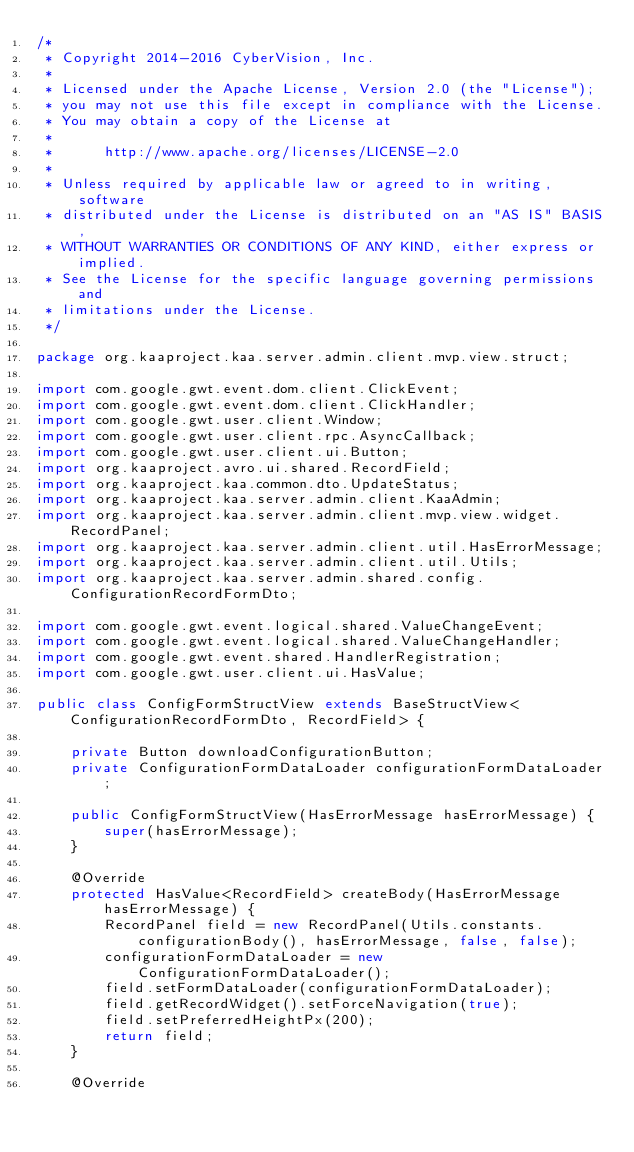Convert code to text. <code><loc_0><loc_0><loc_500><loc_500><_Java_>/*
 * Copyright 2014-2016 CyberVision, Inc.
 *
 * Licensed under the Apache License, Version 2.0 (the "License");
 * you may not use this file except in compliance with the License.
 * You may obtain a copy of the License at
 *
 *      http://www.apache.org/licenses/LICENSE-2.0
 *
 * Unless required by applicable law or agreed to in writing, software
 * distributed under the License is distributed on an "AS IS" BASIS,
 * WITHOUT WARRANTIES OR CONDITIONS OF ANY KIND, either express or implied.
 * See the License for the specific language governing permissions and
 * limitations under the License.
 */

package org.kaaproject.kaa.server.admin.client.mvp.view.struct;

import com.google.gwt.event.dom.client.ClickEvent;
import com.google.gwt.event.dom.client.ClickHandler;
import com.google.gwt.user.client.Window;
import com.google.gwt.user.client.rpc.AsyncCallback;
import com.google.gwt.user.client.ui.Button;
import org.kaaproject.avro.ui.shared.RecordField;
import org.kaaproject.kaa.common.dto.UpdateStatus;
import org.kaaproject.kaa.server.admin.client.KaaAdmin;
import org.kaaproject.kaa.server.admin.client.mvp.view.widget.RecordPanel;
import org.kaaproject.kaa.server.admin.client.util.HasErrorMessage;
import org.kaaproject.kaa.server.admin.client.util.Utils;
import org.kaaproject.kaa.server.admin.shared.config.ConfigurationRecordFormDto;

import com.google.gwt.event.logical.shared.ValueChangeEvent;
import com.google.gwt.event.logical.shared.ValueChangeHandler;
import com.google.gwt.event.shared.HandlerRegistration;
import com.google.gwt.user.client.ui.HasValue;

public class ConfigFormStructView extends BaseStructView<ConfigurationRecordFormDto, RecordField> {

    private Button downloadConfigurationButton;
    private ConfigurationFormDataLoader configurationFormDataLoader;

    public ConfigFormStructView(HasErrorMessage hasErrorMessage) {
        super(hasErrorMessage);
    }

    @Override
    protected HasValue<RecordField> createBody(HasErrorMessage hasErrorMessage) {
        RecordPanel field = new RecordPanel(Utils.constants.configurationBody(), hasErrorMessage, false, false);
        configurationFormDataLoader = new ConfigurationFormDataLoader();
        field.setFormDataLoader(configurationFormDataLoader);
        field.getRecordWidget().setForceNavigation(true);
        field.setPreferredHeightPx(200);
        return field;
    }

    @Override</code> 